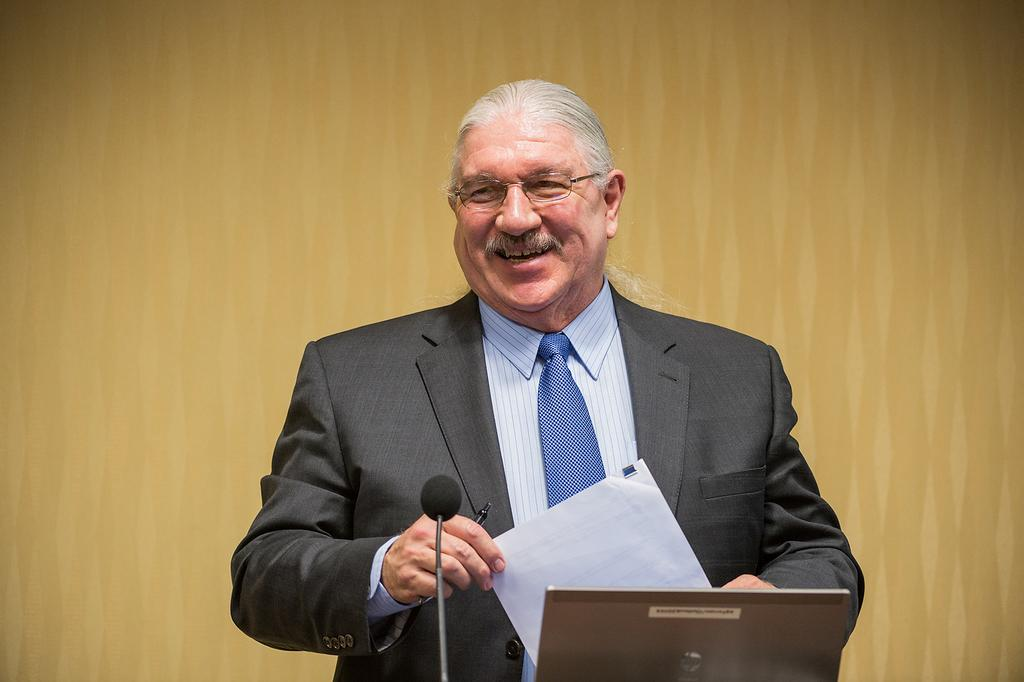What is the main subject of the image? There is a person in the image. What is the person wearing on their upper body? The person is wearing a black blazer, a white shirt, and a blue color tie. What object is in front of the person? There is a microphone in front of the person. What color is the wall in the background? The wall in the background is brown. What type of ink is the person using to write on the microphone? There is no ink or writing present in the image; the person is simply standing in front of the microphone. 